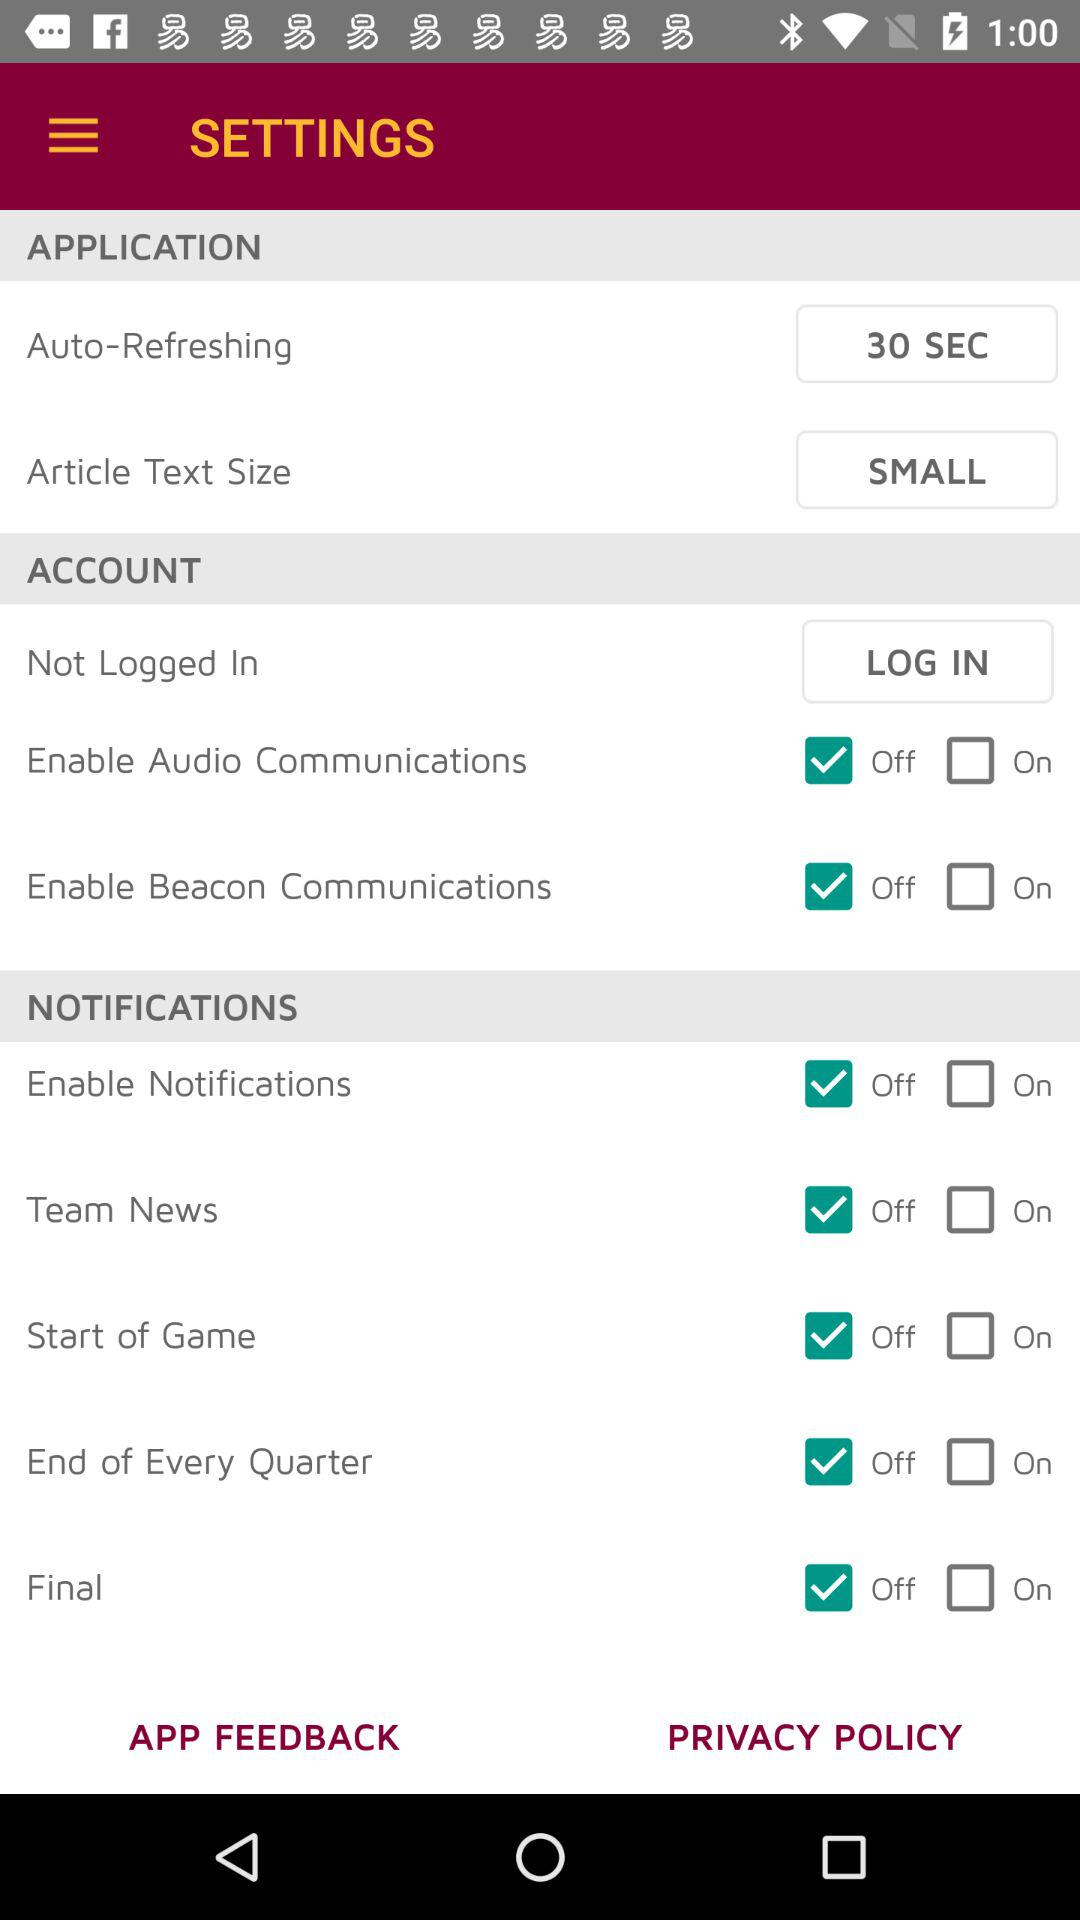What is the status of the "Team News" setting? The status is "off". 